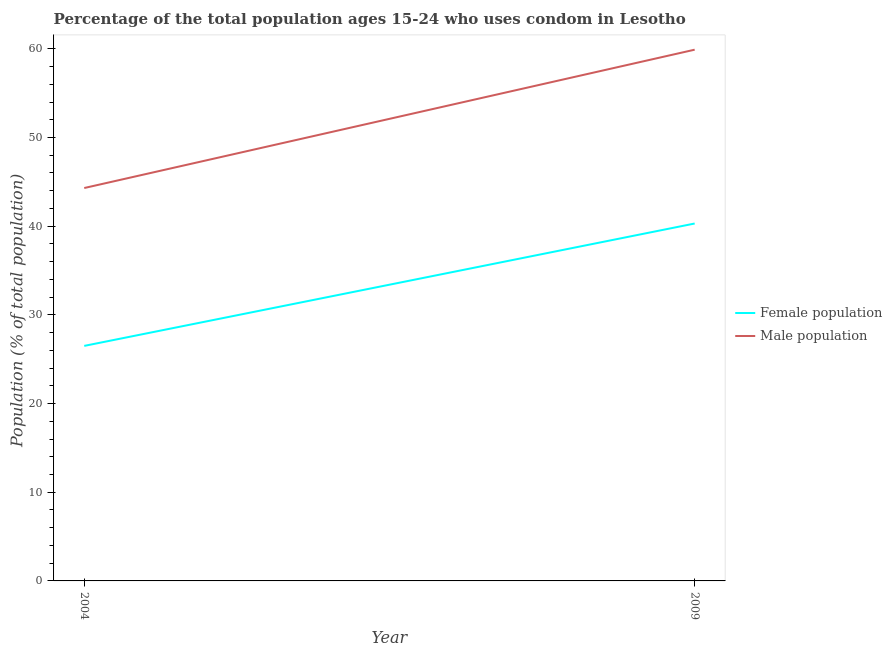Is the number of lines equal to the number of legend labels?
Your answer should be very brief. Yes. What is the male population in 2004?
Give a very brief answer. 44.3. Across all years, what is the maximum female population?
Ensure brevity in your answer.  40.3. Across all years, what is the minimum male population?
Provide a succinct answer. 44.3. In which year was the female population maximum?
Make the answer very short. 2009. In which year was the male population minimum?
Give a very brief answer. 2004. What is the total male population in the graph?
Provide a short and direct response. 104.2. What is the difference between the male population in 2004 and that in 2009?
Make the answer very short. -15.6. What is the difference between the male population in 2009 and the female population in 2004?
Your answer should be very brief. 33.4. What is the average male population per year?
Make the answer very short. 52.1. In the year 2004, what is the difference between the female population and male population?
Ensure brevity in your answer.  -17.8. In how many years, is the female population greater than 22 %?
Your answer should be compact. 2. What is the ratio of the male population in 2004 to that in 2009?
Keep it short and to the point. 0.74. In how many years, is the female population greater than the average female population taken over all years?
Make the answer very short. 1. Is the female population strictly greater than the male population over the years?
Offer a very short reply. No. How many years are there in the graph?
Make the answer very short. 2. What is the difference between two consecutive major ticks on the Y-axis?
Ensure brevity in your answer.  10. Does the graph contain any zero values?
Your response must be concise. No. Does the graph contain grids?
Ensure brevity in your answer.  No. How are the legend labels stacked?
Keep it short and to the point. Vertical. What is the title of the graph?
Offer a very short reply. Percentage of the total population ages 15-24 who uses condom in Lesotho. What is the label or title of the X-axis?
Offer a very short reply. Year. What is the label or title of the Y-axis?
Your answer should be very brief. Population (% of total population) . What is the Population (% of total population)  of Female population in 2004?
Your answer should be very brief. 26.5. What is the Population (% of total population)  of Male population in 2004?
Offer a terse response. 44.3. What is the Population (% of total population)  in Female population in 2009?
Your answer should be compact. 40.3. What is the Population (% of total population)  of Male population in 2009?
Your answer should be very brief. 59.9. Across all years, what is the maximum Population (% of total population)  of Female population?
Your answer should be very brief. 40.3. Across all years, what is the maximum Population (% of total population)  of Male population?
Provide a succinct answer. 59.9. Across all years, what is the minimum Population (% of total population)  of Female population?
Make the answer very short. 26.5. Across all years, what is the minimum Population (% of total population)  of Male population?
Make the answer very short. 44.3. What is the total Population (% of total population)  in Female population in the graph?
Ensure brevity in your answer.  66.8. What is the total Population (% of total population)  in Male population in the graph?
Your answer should be compact. 104.2. What is the difference between the Population (% of total population)  of Male population in 2004 and that in 2009?
Your response must be concise. -15.6. What is the difference between the Population (% of total population)  of Female population in 2004 and the Population (% of total population)  of Male population in 2009?
Your response must be concise. -33.4. What is the average Population (% of total population)  of Female population per year?
Provide a succinct answer. 33.4. What is the average Population (% of total population)  of Male population per year?
Provide a succinct answer. 52.1. In the year 2004, what is the difference between the Population (% of total population)  in Female population and Population (% of total population)  in Male population?
Provide a succinct answer. -17.8. In the year 2009, what is the difference between the Population (% of total population)  of Female population and Population (% of total population)  of Male population?
Provide a short and direct response. -19.6. What is the ratio of the Population (% of total population)  of Female population in 2004 to that in 2009?
Offer a very short reply. 0.66. What is the ratio of the Population (% of total population)  of Male population in 2004 to that in 2009?
Provide a short and direct response. 0.74. What is the difference between the highest and the lowest Population (% of total population)  of Male population?
Provide a succinct answer. 15.6. 